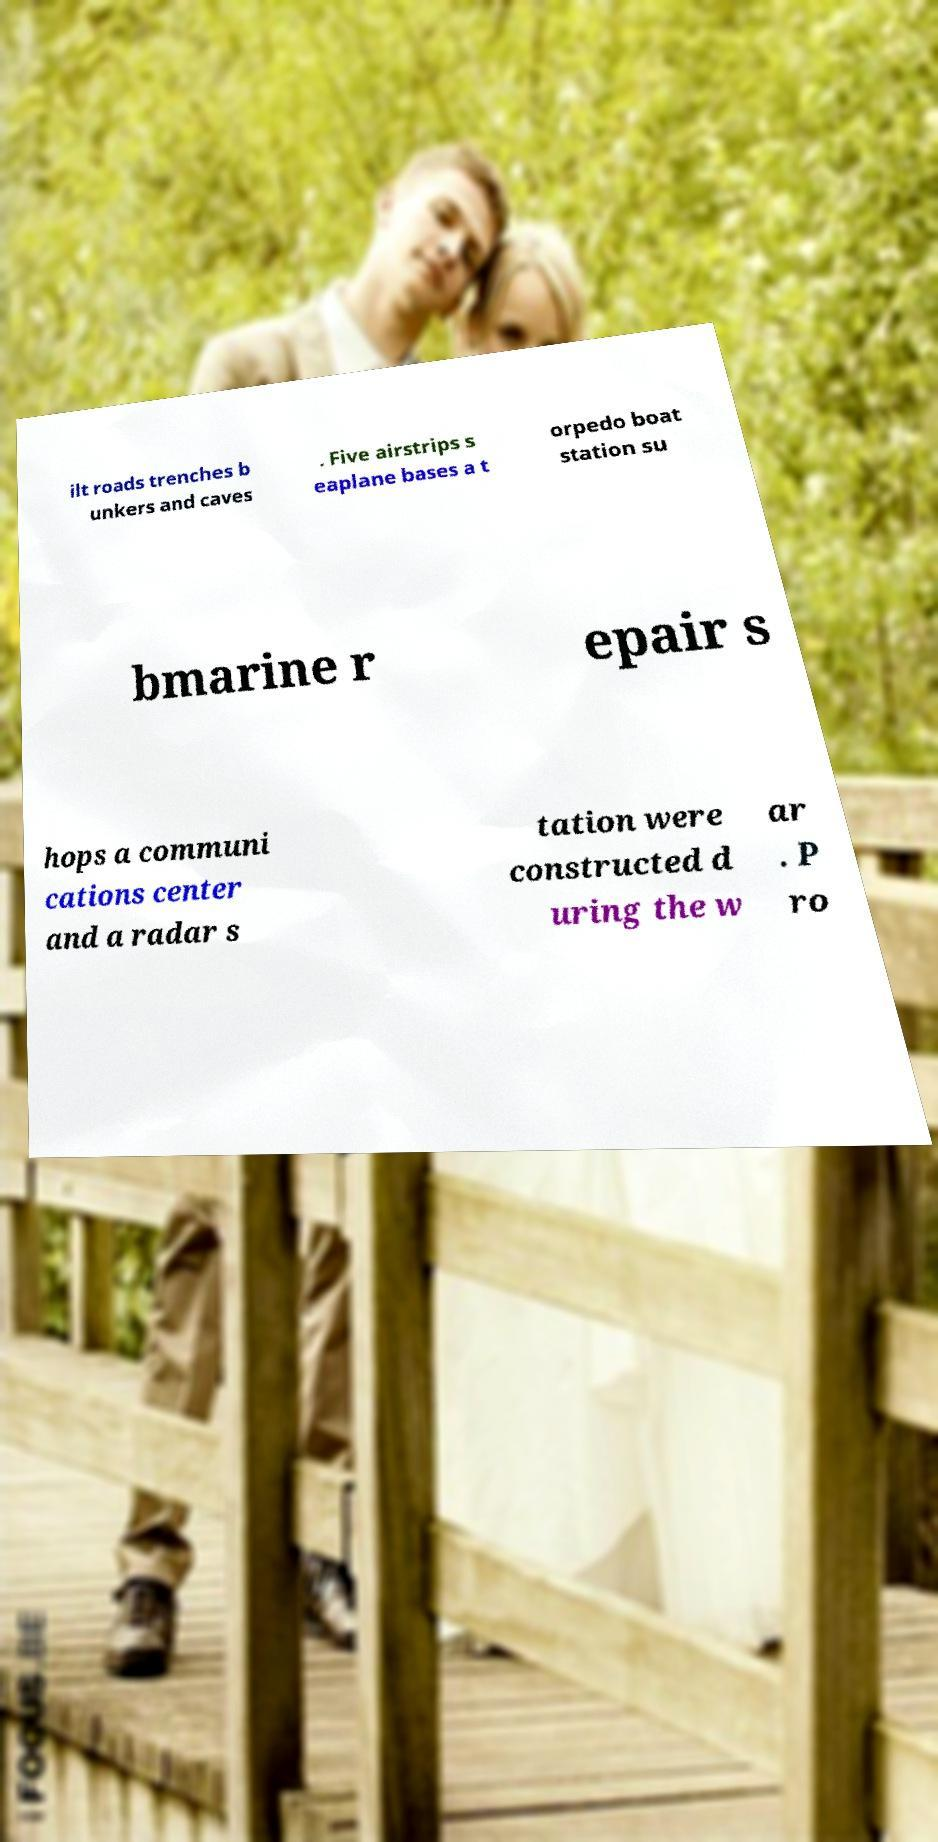Can you accurately transcribe the text from the provided image for me? ilt roads trenches b unkers and caves . Five airstrips s eaplane bases a t orpedo boat station su bmarine r epair s hops a communi cations center and a radar s tation were constructed d uring the w ar . P ro 